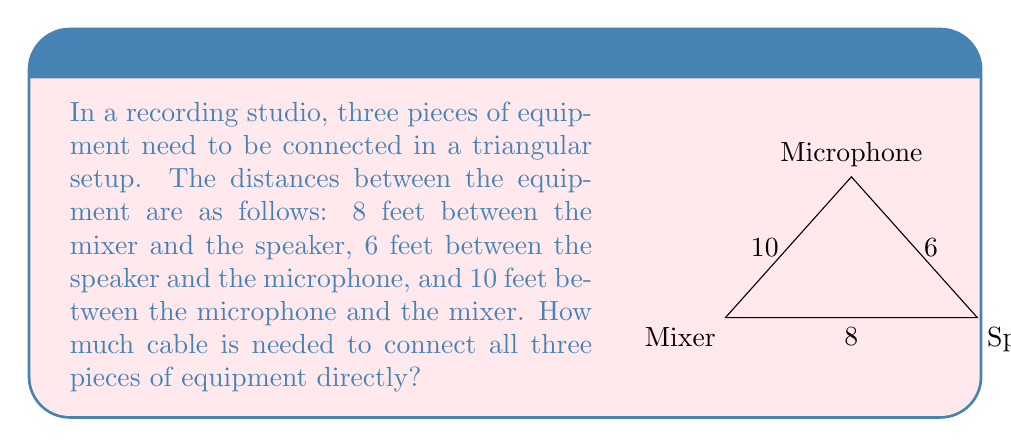Could you help me with this problem? Let's approach this step-by-step:

1) We are given a triangle with side lengths 8, 6, and 10 feet. To find the total length of cable needed, we simply need to add these lengths together.

2) The formula for the perimeter of a triangle is:
   $$P = a + b + c$$
   where $a$, $b$, and $c$ are the lengths of the sides.

3) Substituting our values:
   $$P = 8 + 6 + 10$$

4) Calculating:
   $$P = 24$$

Therefore, the total length of cable needed is 24 feet.

Note: In a real-world scenario, a sound technician might add a small amount of extra length for slack and to account for any elevation differences or obstacles, but for this geometric problem, we're assuming direct connections.
Answer: 24 feet 